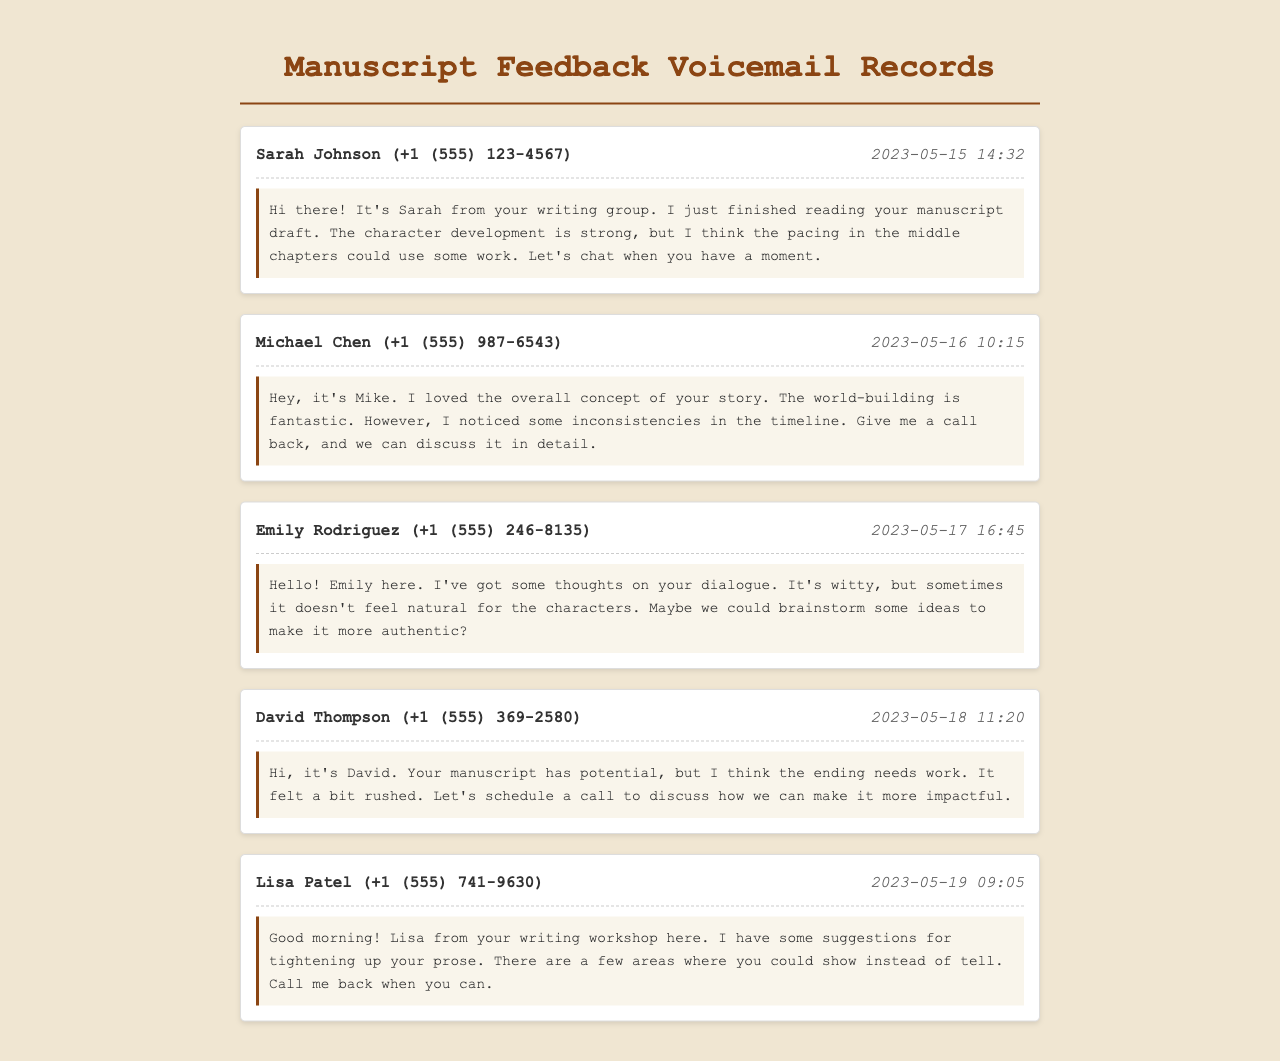What is the name of the first caller? The first caller is mentioned in the document as Sarah Johnson.
Answer: Sarah Johnson What date did Michael Chen leave his voicemail? The voicemail from Michael Chen is dated May 16, 2023.
Answer: 2023-05-16 How many voicemail records are there in total? The document contains five voicemail records from beta readers providing feedback.
Answer: Five What feedback did Emily Rodriguez provide? Emily Rodriguez suggested that the dialogue is witty but sometimes doesn't feel natural for the characters.
Answer: Dialogue What is Lisa Patel's suggestion for the manuscript? Lisa Patel's suggestion is to tighten up the prose and show instead of tell.
Answer: Tightening up prose Which caller mentioned world-building? Michael Chen mentioned that the world-building is fantastic.
Answer: Michael Chen What time did David Thompson leave his voicemail? David Thompson left his voicemail at 11:20.
Answer: 11:20 What aspect of the manuscript did Sarah Johnson think needed work? Sarah Johnson thought the pacing in the middle chapters needed work.
Answer: Pacing Who said the ending felt rushed? David Thompson said that the ending felt rushed.
Answer: David Thompson 